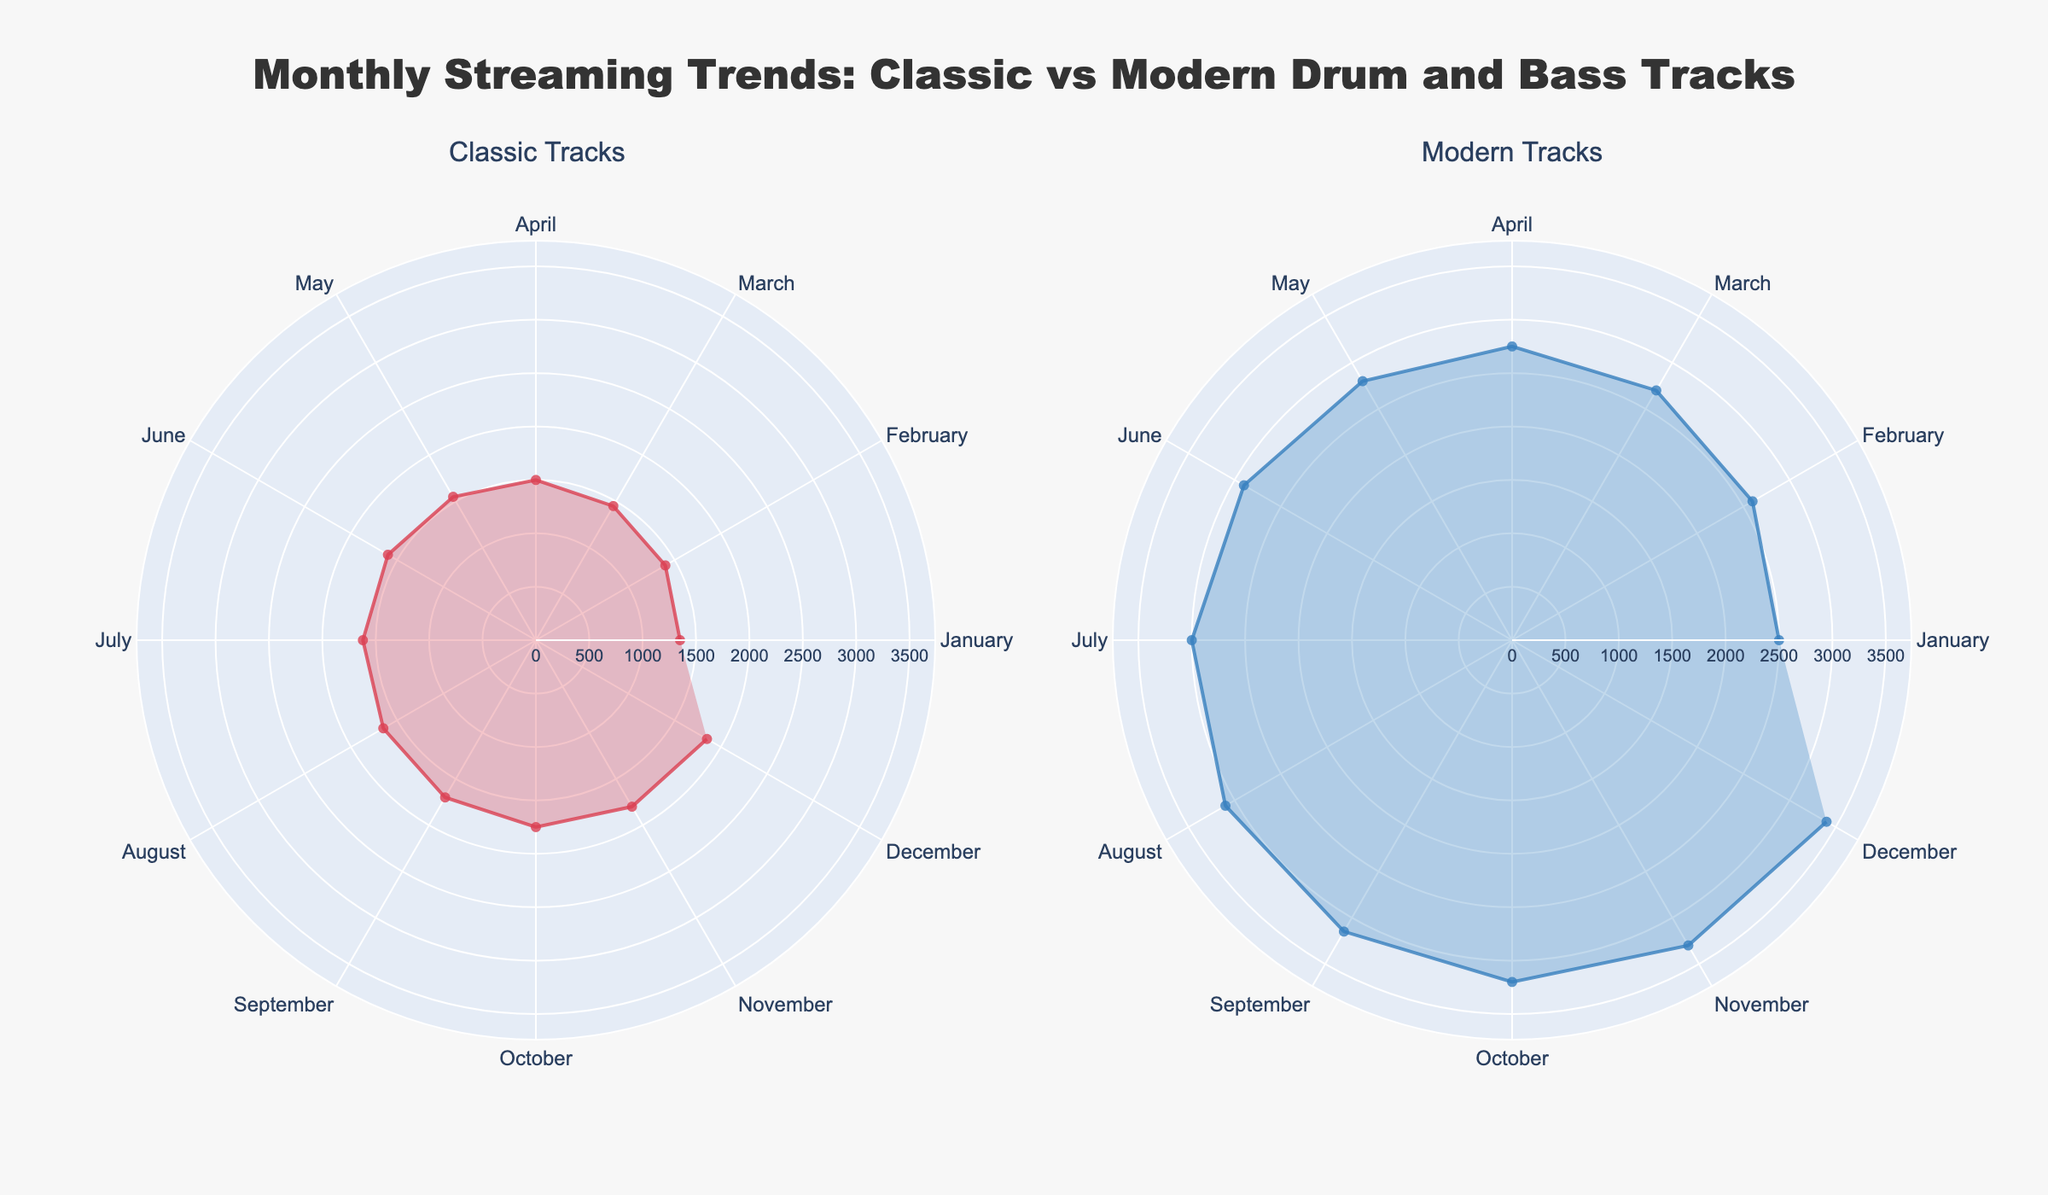When does the maximum streaming of Classic Tracks occur? The maximum streaming of Classic Tracks occurs in December, where the value reaches 1,850 streams according to the Classic Tracks subplot.
Answer: December What's the difference in streaming trends for Modern Tracks between January and February? The number of streams in January is 2,500, and in February it reaches 2,600. Subtracting January's value from February's value gives 2,600 - 2,500 = 100, hence there is an increase of 100 streams from January to February.
Answer: 100 Which month has the smallest difference in streaming between Classic and Modern Tracks? To find the month with the smallest difference, we need to compare the absolute differences for each month. For instance, for January, the difference is 2,500 - 1,350 = 1,150. Here, calculating all months shows June has the smallest difference, with 2,900 (modern) - 1,600 (classic) = 1,300 being relatively consistent with all values.
Answer: June How does the trend for Modern Tracks change from July to November? From July to November, the streaming trend for Modern Tracks increases continuously. July has 3,000 streams, August has 3,100, September has 3,150, October has 3,200, and November peaks at 3,300. The consistent monthly increments reflect an upward trend.
Answer: Upward trend What is the average number of streams for Modern Tracks across the entire year? The total accumulated number of streams for Modern Tracks over the year is the sum of the monthly values: 2,500 + 2,600 + 2,700 + 2,750 + 2,800 + 2,900 + 3,000 + 3,100 + 3,150 + 3,200 + 3,300 + 3,400 = 35,400. Dividing this by 12 months gives an average of 35,400 / 12 = 2,950.
Answer: 2,950 How much higher is the peak of Modern Tracks streaming compared to Classic Tracks? The peak for Modern Tracks is seen in December with 3,400 streams, while the peak for Classic Tracks is also in December with 1,850 streams. The difference is 3,400 - 1,850 = 1,550. Therefore, Modern Tracks peak higher by 1,550 streams.
Answer: 1,550 During which months do Modern Tracks exceed 3,200 streams? Looking at the Modern Tracks subplot, Modern Tracks exceed 3,200 streams in the months of October, November, and December.
Answer: October, November, December What is the range of streaming numbers for Classic Tracks over the year? The range is calculated by subtracting the minimum value from the maximum value. For Classic Tracks, the minimal stream number is 1,350 (January), and the maximum is 1,850 (December). The range is thus 1,850 - 1,350 = 500.
Answer: 500 